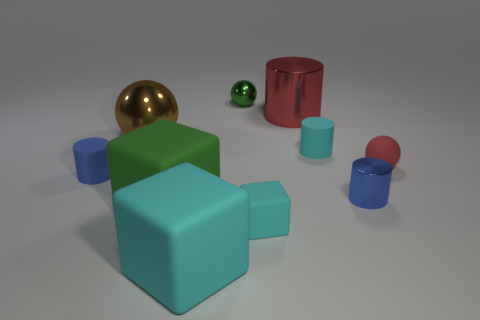There is a ball in front of the brown object; is its color the same as the large cylinder? yes 